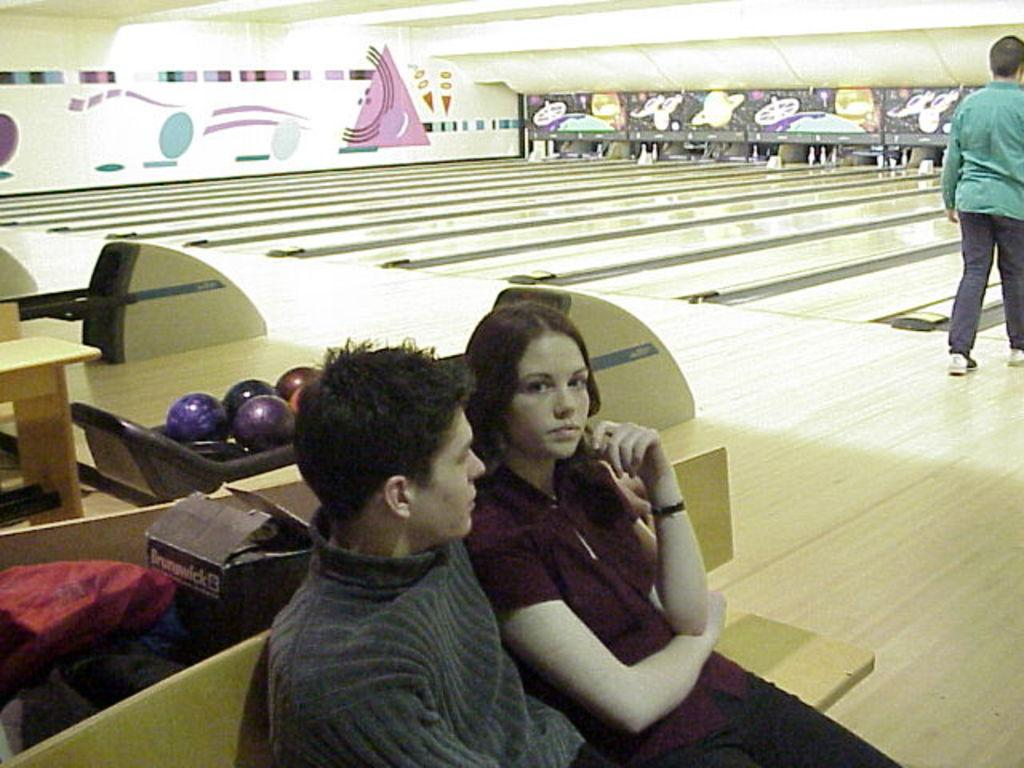Who can be seen sitting on the bench in the image? There is a man and a woman sitting on a bench in the image. Where is the bench located in the image? The bench is at the bottom of the image. What activity is taking place in the image? There is there a bowling area visible? Are there any other people present in the image besides the couple on the bench? Yes, there is a person standing near the bowling area. What type of plant can be seen growing near the bowling area in the image? There is no plant visible near the bowling area in the image. How many cubs are playing near the couple on the bench? There are no cubs present in the image. 